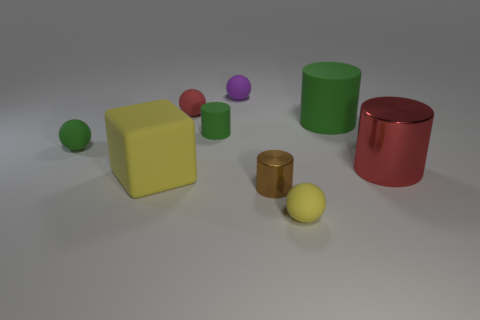What can you say about the sizes of the cylinders compared to the spheres? Observing the image, it looks like the cylinders are significantly larger than the spheres. The red cylinder on the right is the tallest object in the scene and both cylinders have a broader diameter than any of the spheres, indicating a substantial difference in volume as well. 